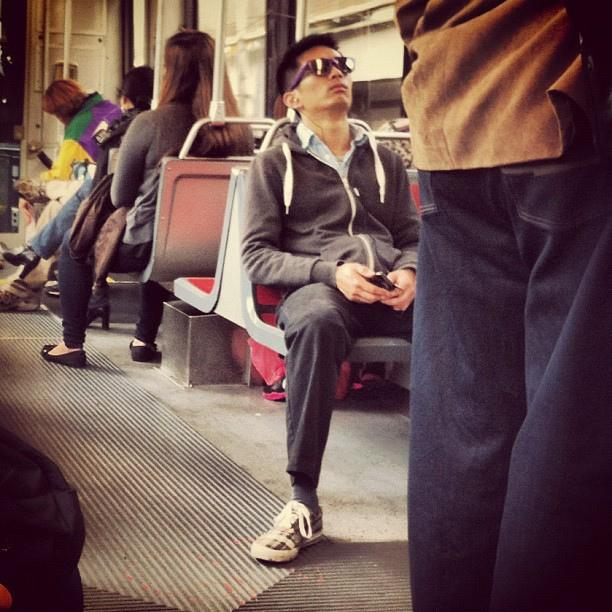How is the boy's sweater done up?

Choices:
A) buttons
B) velcro
C) zipper
D) buckles zipper 